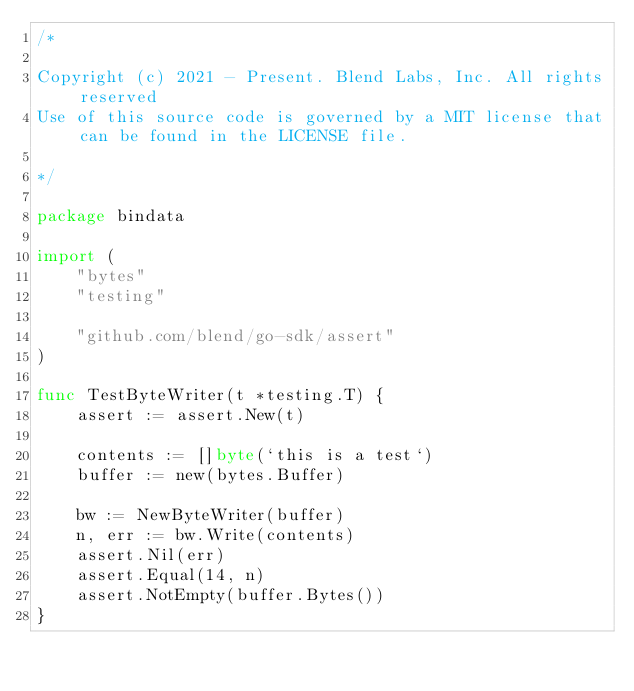Convert code to text. <code><loc_0><loc_0><loc_500><loc_500><_Go_>/*

Copyright (c) 2021 - Present. Blend Labs, Inc. All rights reserved
Use of this source code is governed by a MIT license that can be found in the LICENSE file.

*/

package bindata

import (
	"bytes"
	"testing"

	"github.com/blend/go-sdk/assert"
)

func TestByteWriter(t *testing.T) {
	assert := assert.New(t)

	contents := []byte(`this is a test`)
	buffer := new(bytes.Buffer)

	bw := NewByteWriter(buffer)
	n, err := bw.Write(contents)
	assert.Nil(err)
	assert.Equal(14, n)
	assert.NotEmpty(buffer.Bytes())
}
</code> 